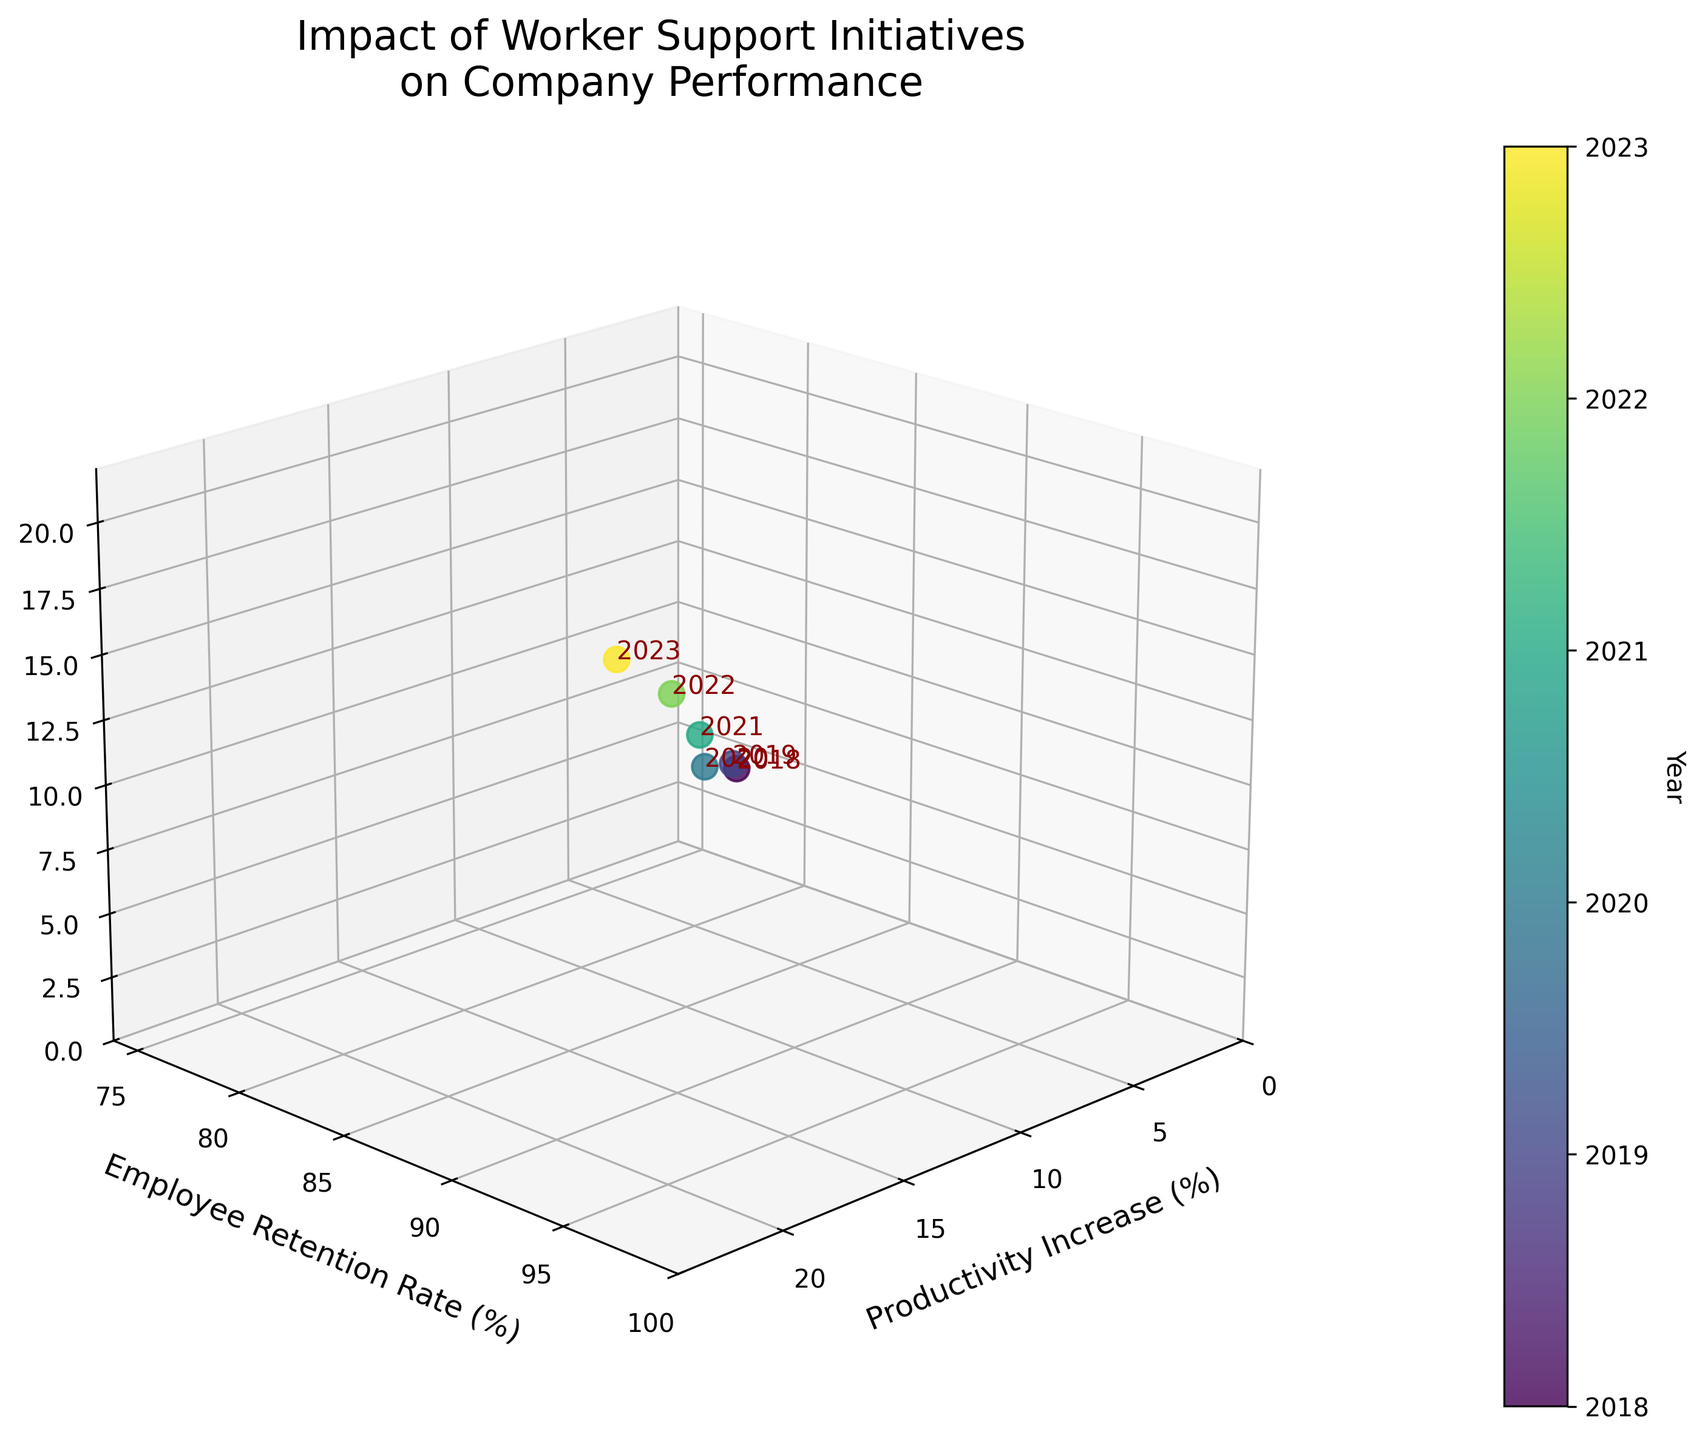What's the title of the figure? The title is written at the top of the figure. It reads "Impact of Worker Support Initiatives on Company Performance."
Answer: Impact of Worker Support Initiatives on Company Performance How many data points are represented in the plot? Each data point corresponds to a specific year indicated by the labels in the plot. There are 6 years visible: 2018, 2019, 2020, 2021, 2022, 2023.
Answer: 6 Which year shows the highest productivity increase? Look at the x-axis and find the data point with the highest value. The year label at this point is 2023.
Answer: 2023 What is the productivity increase in 2020? Locate 2020 in the plot. The x-coordinate of this point indicates the productivity increase, which is 12%.
Answer: 12% Compare the employee retention rate between 2018 and 2023. Which year has a higher retention rate? Find the plot points for 2018 and 2023. Check the y-axis coordinate values; 2023 has a retention rate of 95%, and 2018 has 82%.
Answer: 2023 What is the average revenue growth across all years? Sum the z-axis values for all years (7 + 9 + 11 + 14 + 17 + 20 = 78). Divide by 6 (78 / 6 = 13).
Answer: 13% What's the trend in productivity increase from 2018 to 2023? Observe the x-axis values from 2018 to 2023. The values consistently increase each year from 5% to 22%.
Answer: Increasing Which year has the most significant improvement in employee retention rate compared to the previous year? Compare the annual differences in the y-axis values. The largest difference is from 2021 to 2022 (93% - 91% = 2%).
Answer: 2022 What is the relationship between productivity increase and revenue growth in 2023? For 2023, check the x-axis and z-axis values. Both values are relatively high with x = 22% and z = 20%. A higher productivity increase correlates with higher revenue growth.
Answer: Positive correlation Is there any year when revenue growth decreased compared to the previous year? Examine the z-axis value of each subsequent year. No values decrease; they all increase consecutively from 2018 to 2023.
Answer: No 